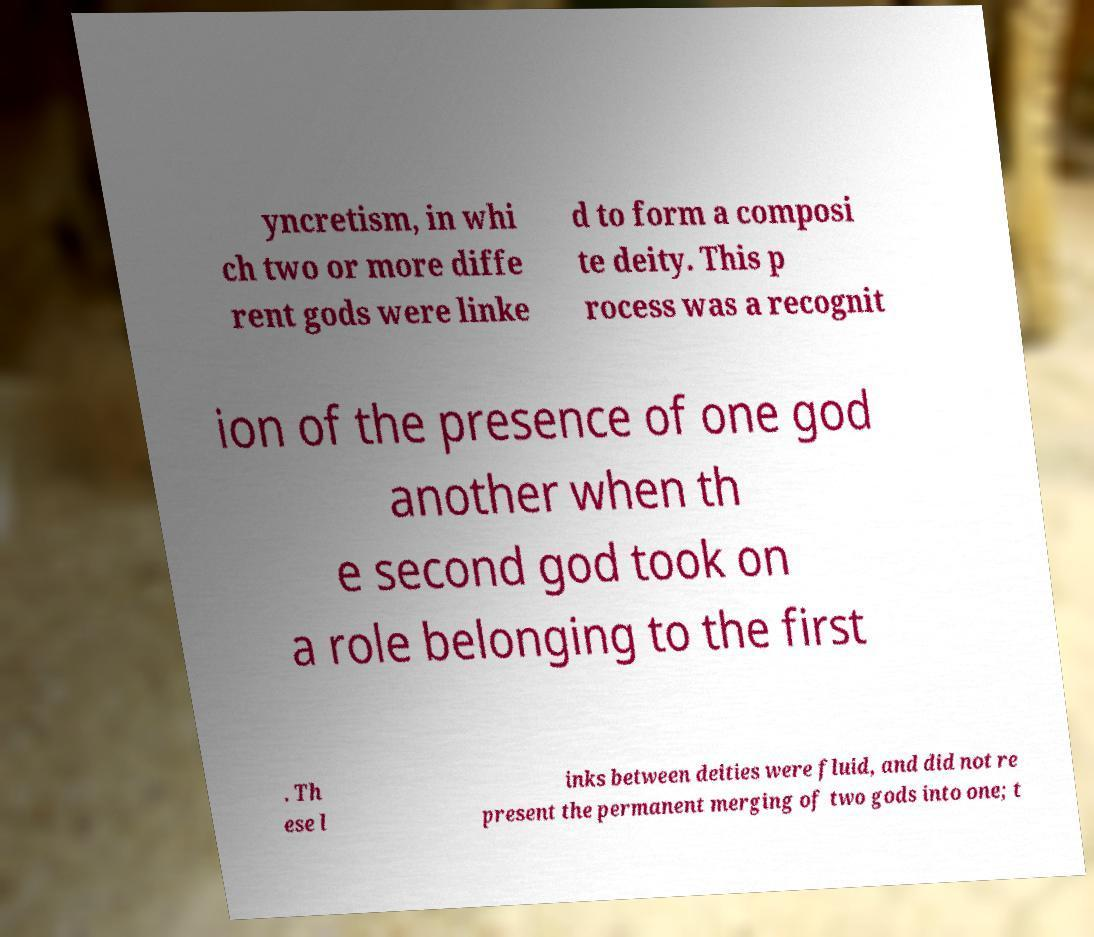Please identify and transcribe the text found in this image. yncretism, in whi ch two or more diffe rent gods were linke d to form a composi te deity. This p rocess was a recognit ion of the presence of one god another when th e second god took on a role belonging to the first . Th ese l inks between deities were fluid, and did not re present the permanent merging of two gods into one; t 